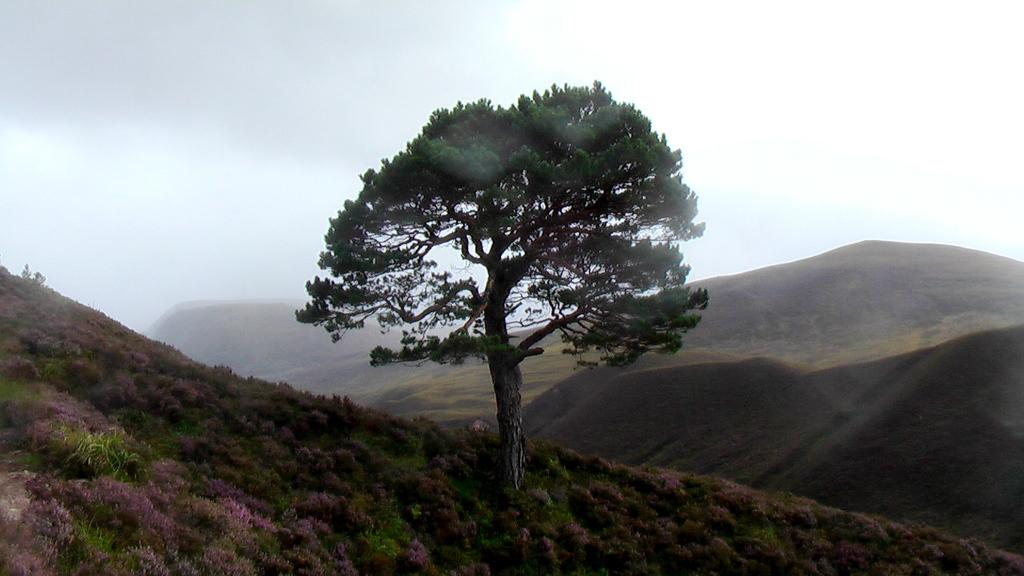What types of vegetation can be seen in the foreground of the image? There are plants and a tree in the foreground of the image. What natural features are visible in the background of the image? There are mountains and the sky visible in the background of the image. What type of jeans is the tree wearing in the image? There are no jeans present in the image, as trees do not wear clothing. 